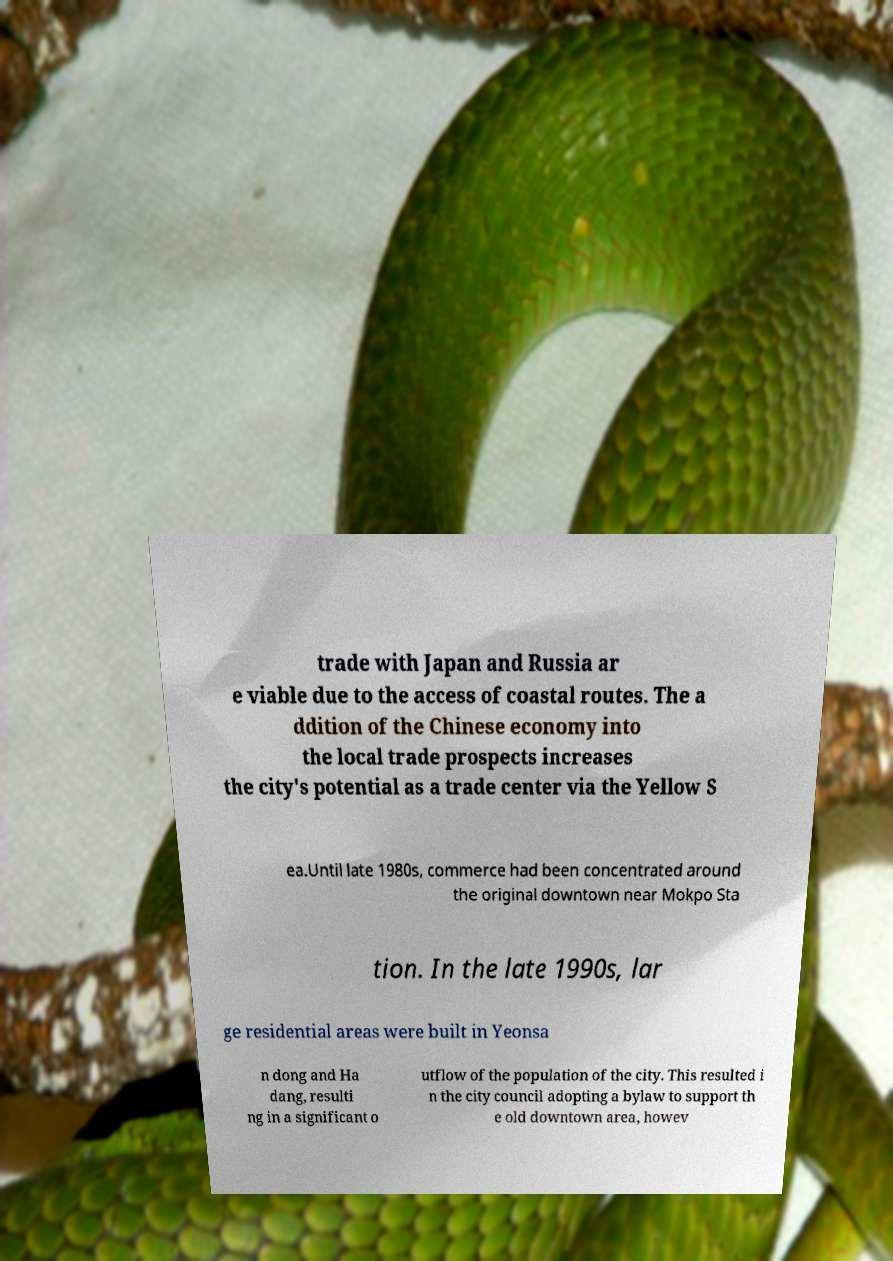Could you extract and type out the text from this image? trade with Japan and Russia ar e viable due to the access of coastal routes. The a ddition of the Chinese economy into the local trade prospects increases the city's potential as a trade center via the Yellow S ea.Until late 1980s, commerce had been concentrated around the original downtown near Mokpo Sta tion. In the late 1990s, lar ge residential areas were built in Yeonsa n dong and Ha dang, resulti ng in a significant o utflow of the population of the city. This resulted i n the city council adopting a bylaw to support th e old downtown area, howev 